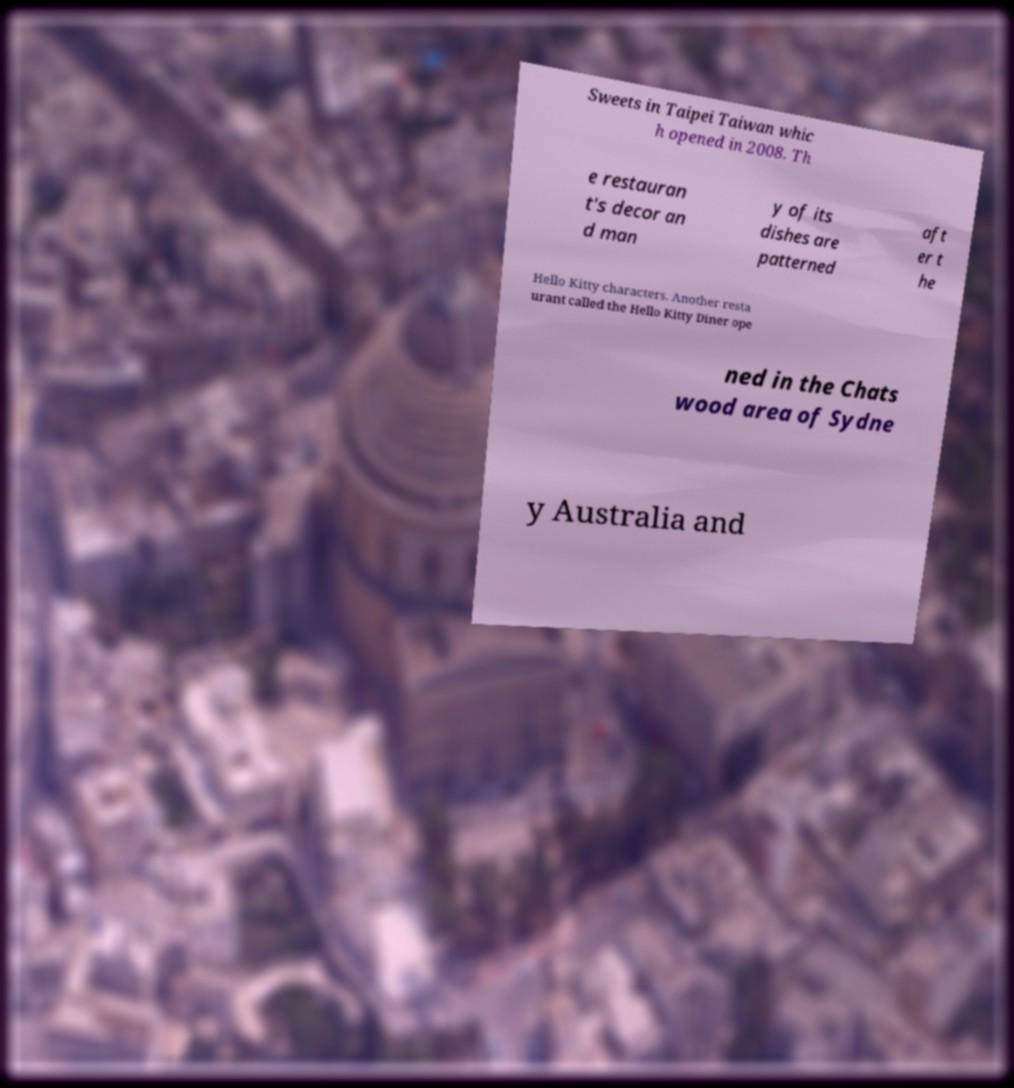For documentation purposes, I need the text within this image transcribed. Could you provide that? Sweets in Taipei Taiwan whic h opened in 2008. Th e restauran t's decor an d man y of its dishes are patterned aft er t he Hello Kitty characters. Another resta urant called the Hello Kitty Diner ope ned in the Chats wood area of Sydne y Australia and 